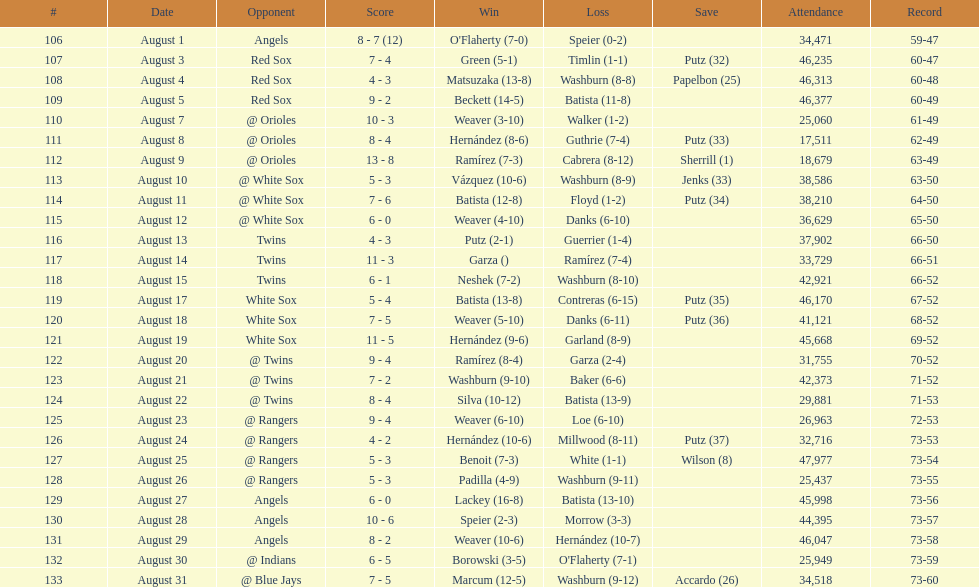How many defeats occurred throughout the stretch? 7. 